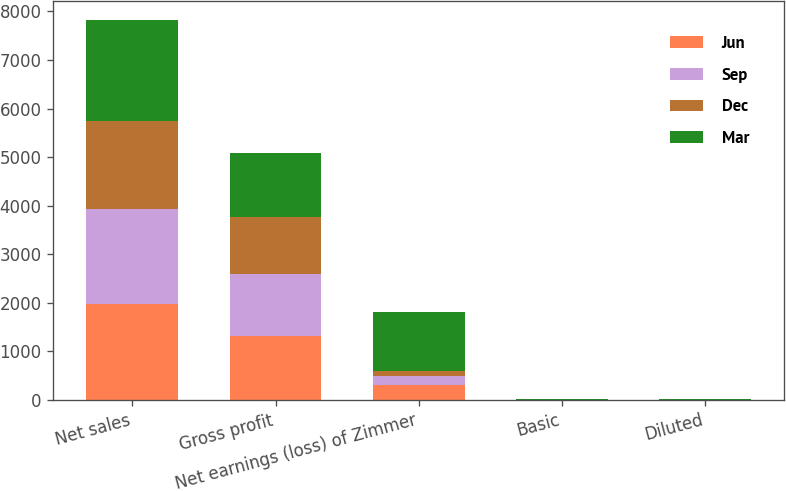<chart> <loc_0><loc_0><loc_500><loc_500><stacked_bar_chart><ecel><fcel>Net sales<fcel>Gross profit<fcel>Net earnings (loss) of Zimmer<fcel>Basic<fcel>Diluted<nl><fcel>Jun<fcel>1977.3<fcel>1312.4<fcel>299.4<fcel>1.49<fcel>1.47<nl><fcel>Sep<fcel>1954.4<fcel>1279<fcel>184.2<fcel>0.91<fcel>0.9<nl><fcel>Dec<fcel>1818.1<fcel>1164.5<fcel>98.8<fcel>0.49<fcel>0.48<nl><fcel>Mar<fcel>2074.3<fcel>1331.4<fcel>1231.4<fcel>6.08<fcel>6.03<nl></chart> 